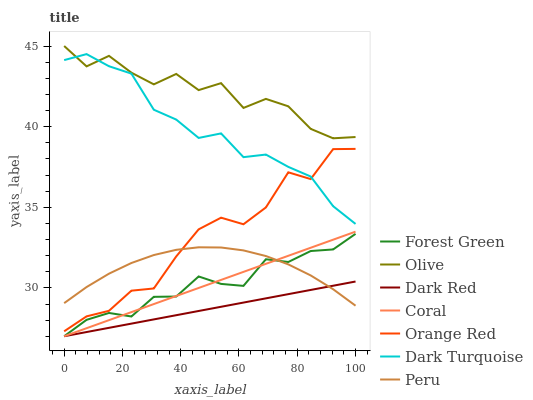Does Dark Red have the minimum area under the curve?
Answer yes or no. Yes. Does Olive have the maximum area under the curve?
Answer yes or no. Yes. Does Coral have the minimum area under the curve?
Answer yes or no. No. Does Coral have the maximum area under the curve?
Answer yes or no. No. Is Dark Red the smoothest?
Answer yes or no. Yes. Is Orange Red the roughest?
Answer yes or no. Yes. Is Coral the smoothest?
Answer yes or no. No. Is Coral the roughest?
Answer yes or no. No. Does Dark Red have the lowest value?
Answer yes or no. Yes. Does Peru have the lowest value?
Answer yes or no. No. Does Olive have the highest value?
Answer yes or no. Yes. Does Coral have the highest value?
Answer yes or no. No. Is Dark Red less than Olive?
Answer yes or no. Yes. Is Olive greater than Dark Red?
Answer yes or no. Yes. Does Dark Red intersect Forest Green?
Answer yes or no. Yes. Is Dark Red less than Forest Green?
Answer yes or no. No. Is Dark Red greater than Forest Green?
Answer yes or no. No. Does Dark Red intersect Olive?
Answer yes or no. No. 